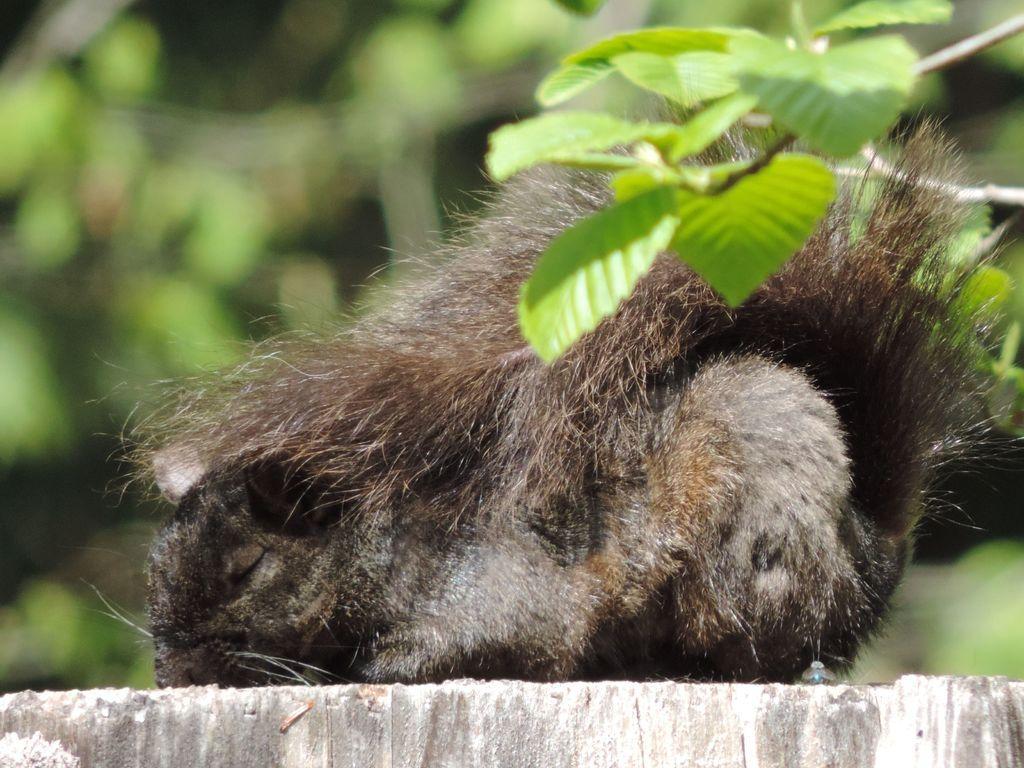How would you summarize this image in a sentence or two? In the image we can see an animal, brown and white in color. Here we can see the leaves and the background is blurred. 